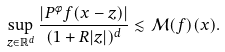Convert formula to latex. <formula><loc_0><loc_0><loc_500><loc_500>\sup _ { z \in \mathbb { R } ^ { d } } \frac { | P ^ { \phi } f ( x - z ) | } { ( 1 + R | z | ) ^ { d } } \lesssim \mathcal { M } ( f ) ( x ) .</formula> 